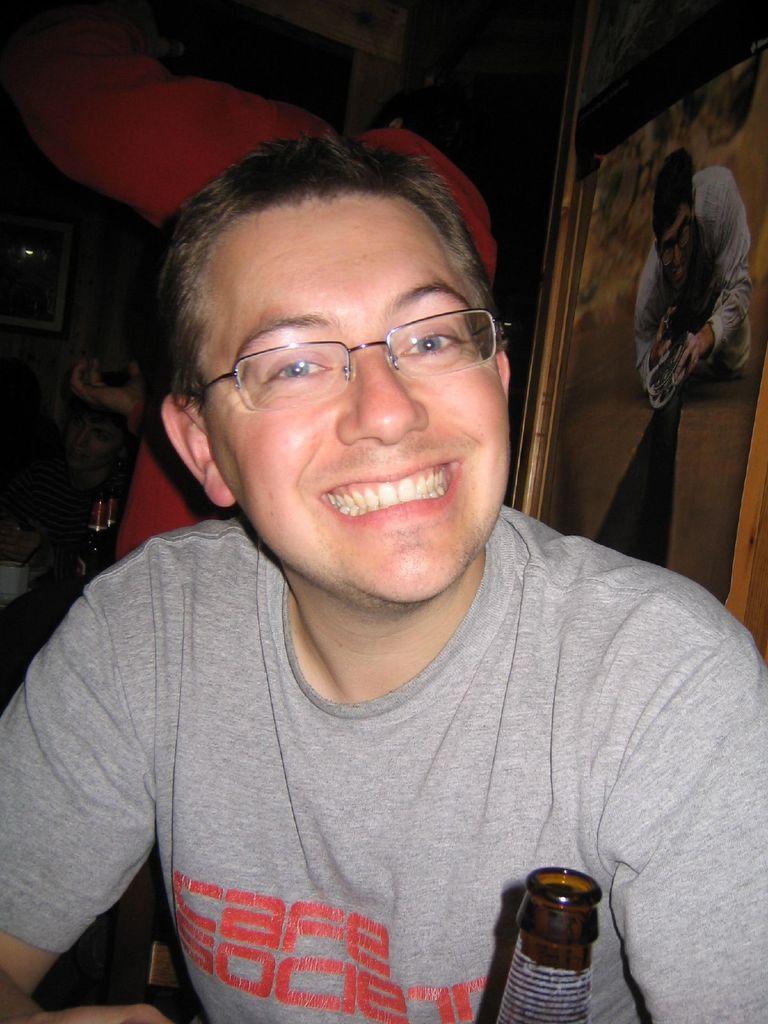Please provide a concise description of this image. In this image we can see a person. Behind the person we can see persons and bottles. On the right side, we can see a poster. In the poster we can see a person. On the left side, we can see a photo frame. At the bottom we can see a bottle. 